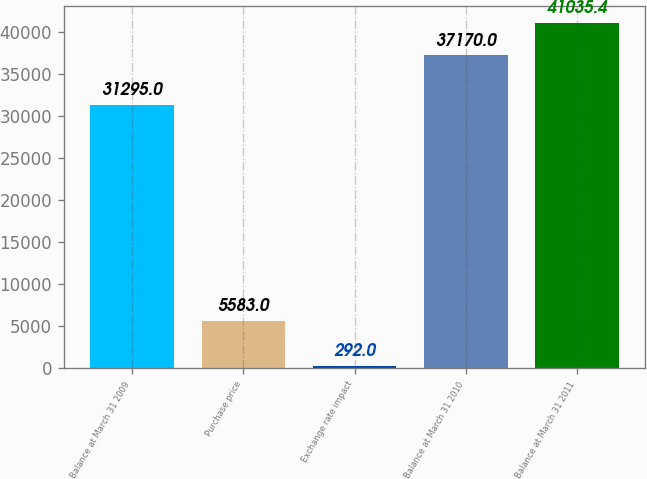Convert chart to OTSL. <chart><loc_0><loc_0><loc_500><loc_500><bar_chart><fcel>Balance at March 31 2009<fcel>Purchase price<fcel>Exchange rate impact<fcel>Balance at March 31 2010<fcel>Balance at March 31 2011<nl><fcel>31295<fcel>5583<fcel>292<fcel>37170<fcel>41035.4<nl></chart> 